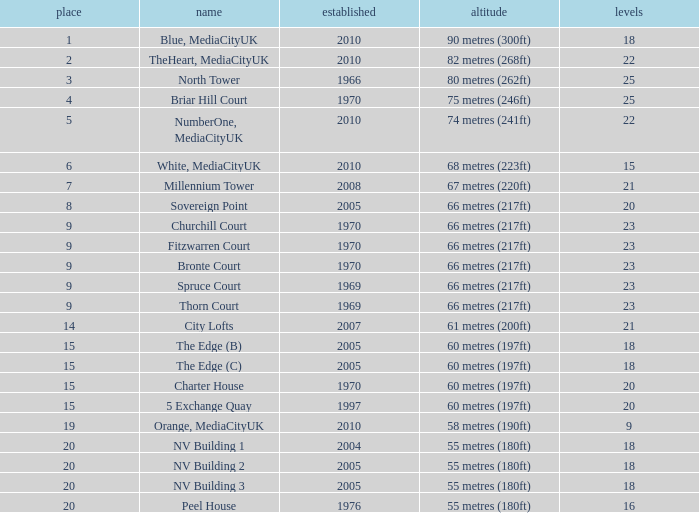What is Height, when Rank is less than 20, when Floors is greater than 9, when Built is 2005, and when Name is The Edge (C)? 60 metres (197ft). 